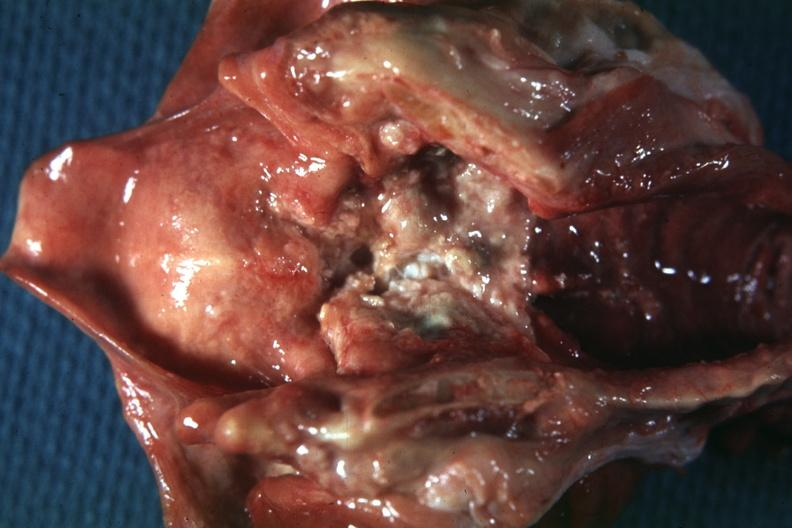what does this image show?
Answer the question using a single word or phrase. Excellent very large ulcerative lesion 